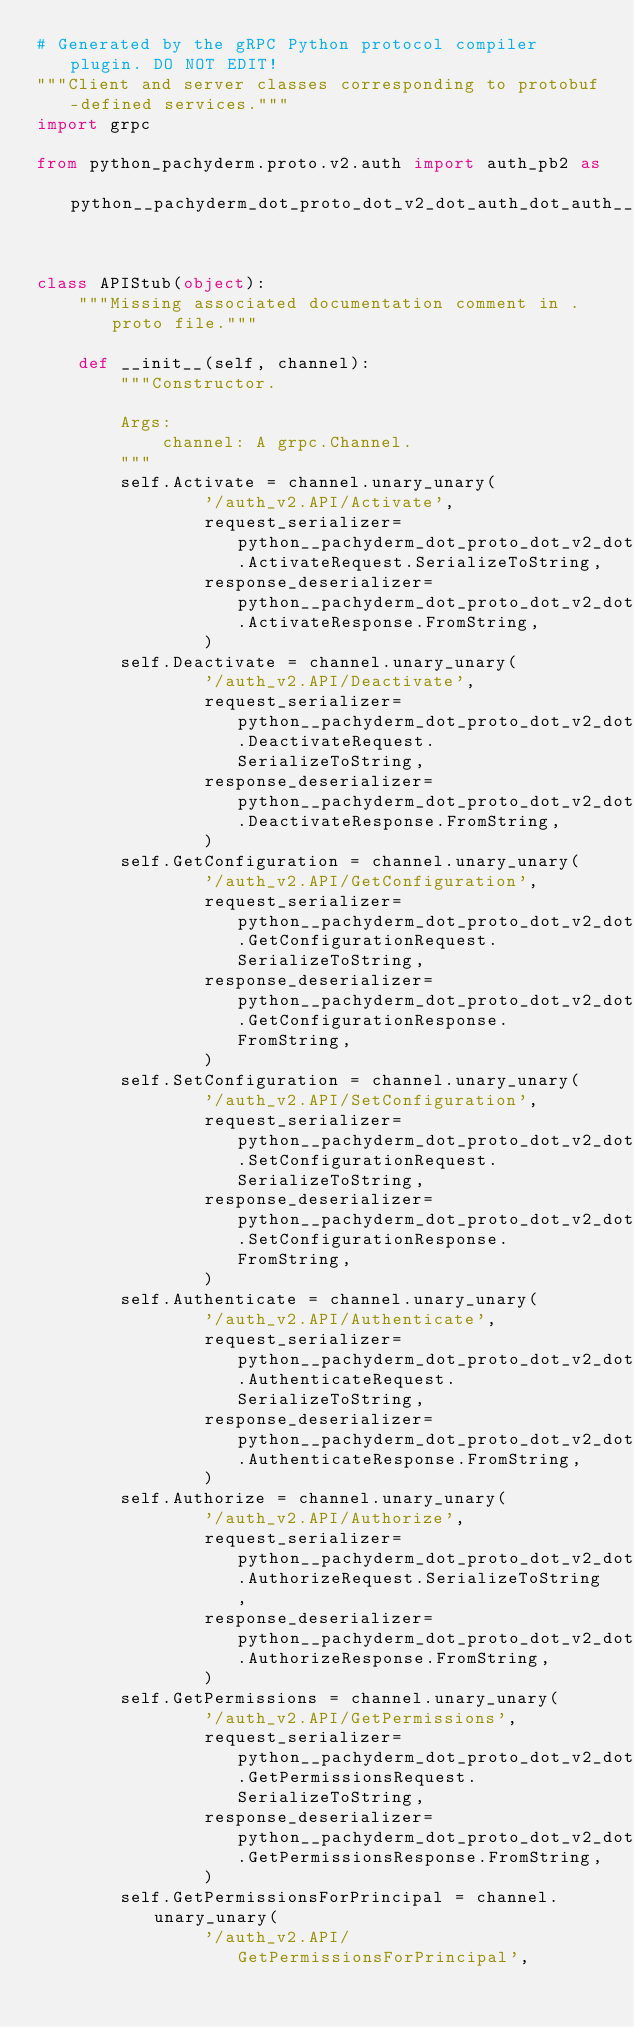Convert code to text. <code><loc_0><loc_0><loc_500><loc_500><_Python_># Generated by the gRPC Python protocol compiler plugin. DO NOT EDIT!
"""Client and server classes corresponding to protobuf-defined services."""
import grpc

from python_pachyderm.proto.v2.auth import auth_pb2 as python__pachyderm_dot_proto_dot_v2_dot_auth_dot_auth__pb2


class APIStub(object):
    """Missing associated documentation comment in .proto file."""

    def __init__(self, channel):
        """Constructor.

        Args:
            channel: A grpc.Channel.
        """
        self.Activate = channel.unary_unary(
                '/auth_v2.API/Activate',
                request_serializer=python__pachyderm_dot_proto_dot_v2_dot_auth_dot_auth__pb2.ActivateRequest.SerializeToString,
                response_deserializer=python__pachyderm_dot_proto_dot_v2_dot_auth_dot_auth__pb2.ActivateResponse.FromString,
                )
        self.Deactivate = channel.unary_unary(
                '/auth_v2.API/Deactivate',
                request_serializer=python__pachyderm_dot_proto_dot_v2_dot_auth_dot_auth__pb2.DeactivateRequest.SerializeToString,
                response_deserializer=python__pachyderm_dot_proto_dot_v2_dot_auth_dot_auth__pb2.DeactivateResponse.FromString,
                )
        self.GetConfiguration = channel.unary_unary(
                '/auth_v2.API/GetConfiguration',
                request_serializer=python__pachyderm_dot_proto_dot_v2_dot_auth_dot_auth__pb2.GetConfigurationRequest.SerializeToString,
                response_deserializer=python__pachyderm_dot_proto_dot_v2_dot_auth_dot_auth__pb2.GetConfigurationResponse.FromString,
                )
        self.SetConfiguration = channel.unary_unary(
                '/auth_v2.API/SetConfiguration',
                request_serializer=python__pachyderm_dot_proto_dot_v2_dot_auth_dot_auth__pb2.SetConfigurationRequest.SerializeToString,
                response_deserializer=python__pachyderm_dot_proto_dot_v2_dot_auth_dot_auth__pb2.SetConfigurationResponse.FromString,
                )
        self.Authenticate = channel.unary_unary(
                '/auth_v2.API/Authenticate',
                request_serializer=python__pachyderm_dot_proto_dot_v2_dot_auth_dot_auth__pb2.AuthenticateRequest.SerializeToString,
                response_deserializer=python__pachyderm_dot_proto_dot_v2_dot_auth_dot_auth__pb2.AuthenticateResponse.FromString,
                )
        self.Authorize = channel.unary_unary(
                '/auth_v2.API/Authorize',
                request_serializer=python__pachyderm_dot_proto_dot_v2_dot_auth_dot_auth__pb2.AuthorizeRequest.SerializeToString,
                response_deserializer=python__pachyderm_dot_proto_dot_v2_dot_auth_dot_auth__pb2.AuthorizeResponse.FromString,
                )
        self.GetPermissions = channel.unary_unary(
                '/auth_v2.API/GetPermissions',
                request_serializer=python__pachyderm_dot_proto_dot_v2_dot_auth_dot_auth__pb2.GetPermissionsRequest.SerializeToString,
                response_deserializer=python__pachyderm_dot_proto_dot_v2_dot_auth_dot_auth__pb2.GetPermissionsResponse.FromString,
                )
        self.GetPermissionsForPrincipal = channel.unary_unary(
                '/auth_v2.API/GetPermissionsForPrincipal',</code> 